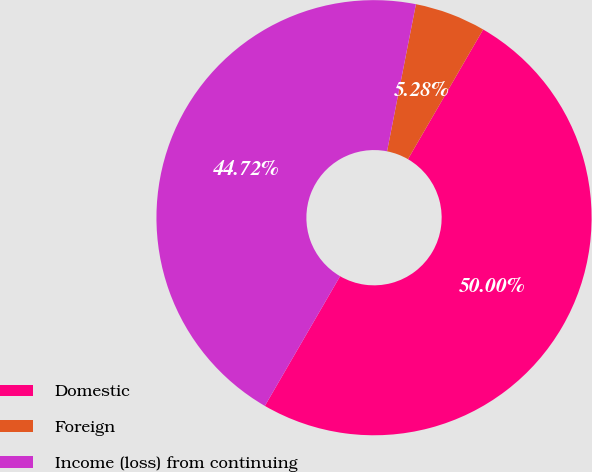Convert chart. <chart><loc_0><loc_0><loc_500><loc_500><pie_chart><fcel>Domestic<fcel>Foreign<fcel>Income (loss) from continuing<nl><fcel>50.0%<fcel>5.28%<fcel>44.72%<nl></chart> 